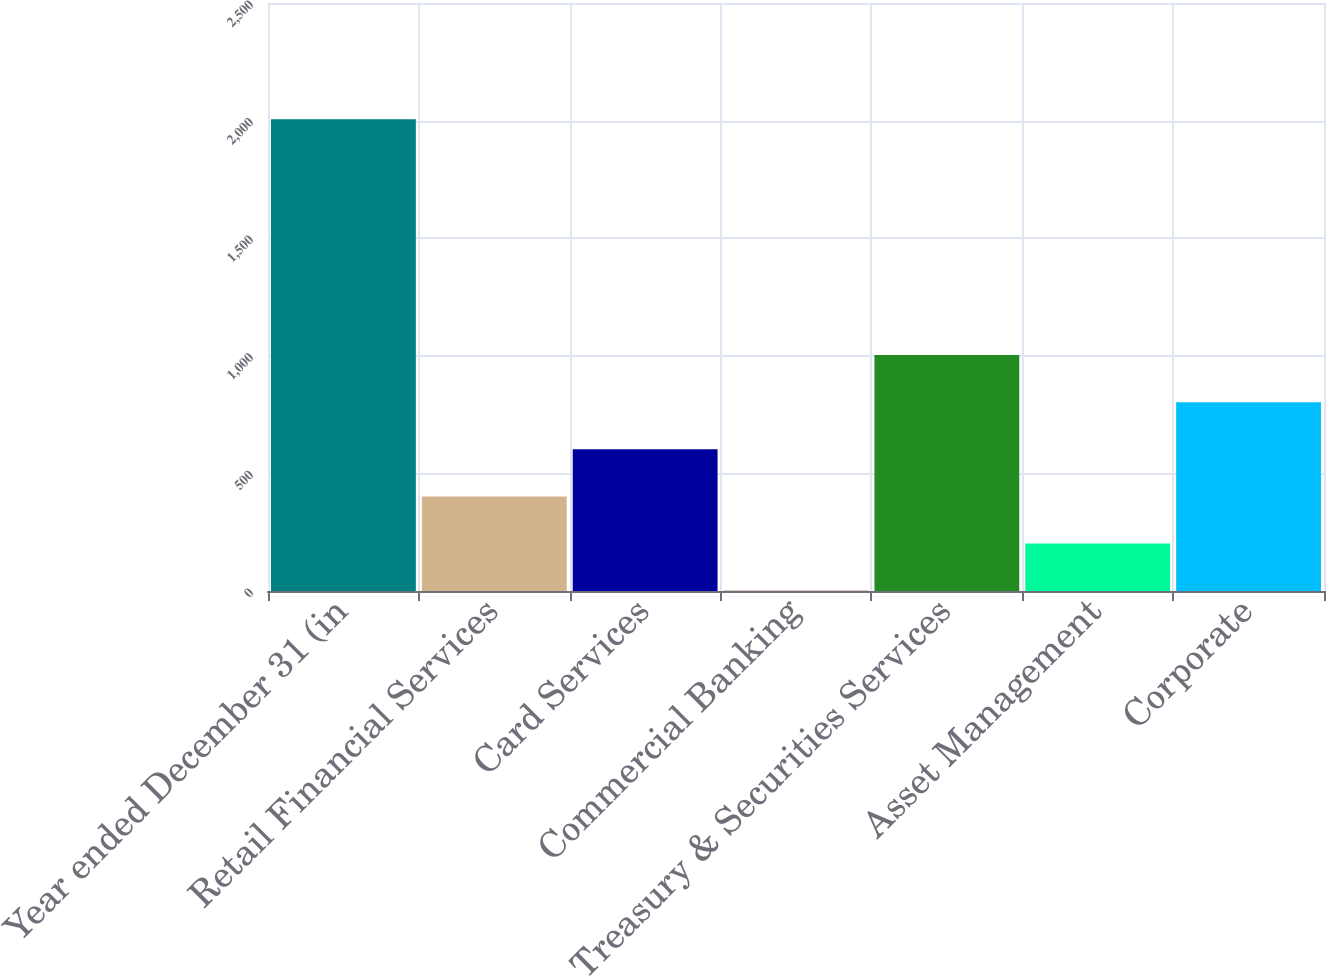<chart> <loc_0><loc_0><loc_500><loc_500><bar_chart><fcel>Year ended December 31 (in<fcel>Retail Financial Services<fcel>Card Services<fcel>Commercial Banking<fcel>Treasury & Securities Services<fcel>Asset Management<fcel>Corporate<nl><fcel>2006<fcel>402<fcel>602.5<fcel>1<fcel>1003.5<fcel>201.5<fcel>803<nl></chart> 